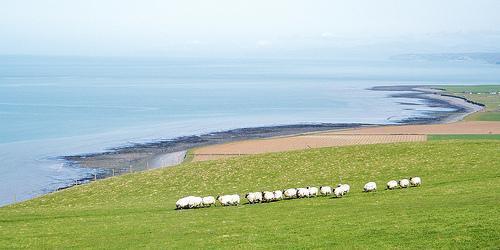How many sheeps are not in a line?
Give a very brief answer. 1. 